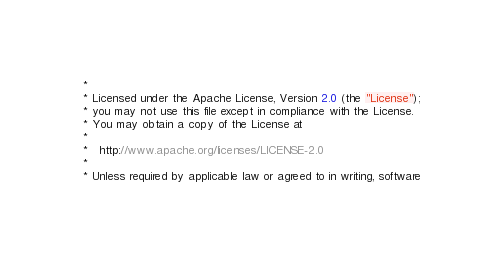<code> <loc_0><loc_0><loc_500><loc_500><_Cuda_> *
 * Licensed under the Apache License, Version 2.0 (the "License"); 
 * you may not use this file except in compliance with the License.  
 * You may obtain a copy of the License at
 *
 *   http://www.apache.org/licenses/LICENSE-2.0
 *
 * Unless required by applicable law or agreed to in writing, software </code> 